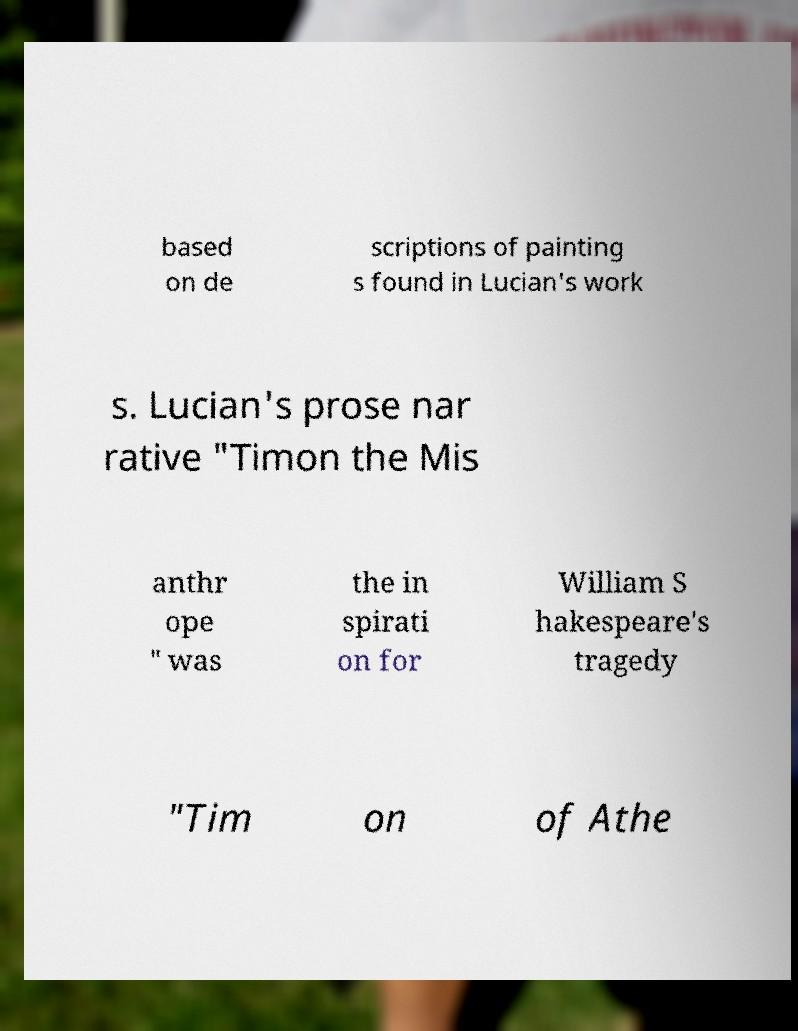Can you accurately transcribe the text from the provided image for me? based on de scriptions of painting s found in Lucian's work s. Lucian's prose nar rative "Timon the Mis anthr ope " was the in spirati on for William S hakespeare's tragedy "Tim on of Athe 